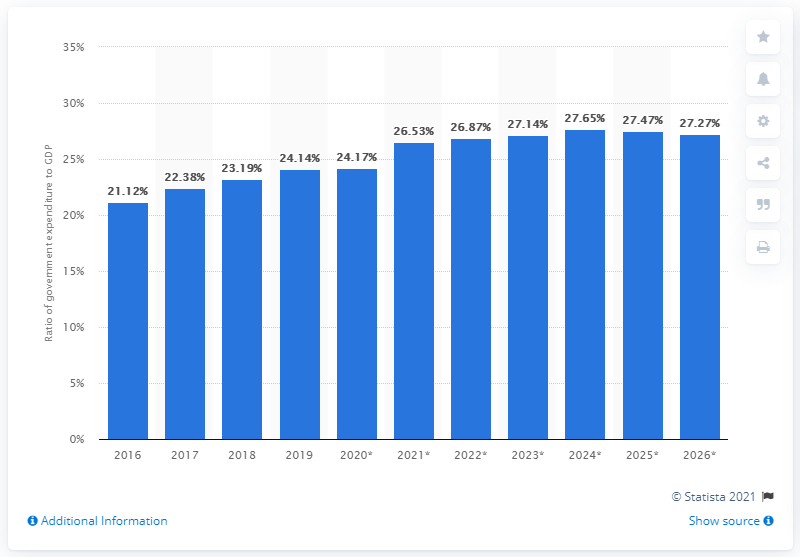Give some essential details in this illustration. In 2019, government expenditure accounted for approximately 24.17% of Cambodia's GDP. 